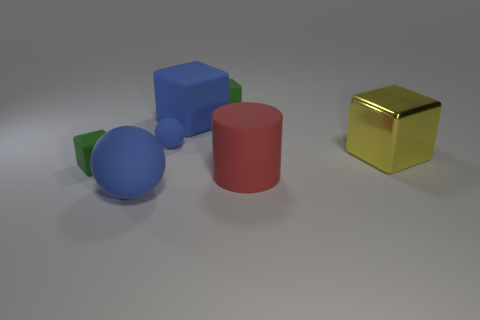How many cubes are made of the same material as the large red cylinder?
Give a very brief answer. 3. What number of shiny cubes are the same size as the rubber cylinder?
Give a very brief answer. 1. What material is the blue ball in front of the green rubber cube that is on the left side of the small blue thing behind the red rubber cylinder made of?
Offer a very short reply. Rubber. What number of things are small green metallic cubes or big red rubber objects?
Offer a terse response. 1. Are there any other things that have the same material as the yellow block?
Offer a terse response. No. There is a tiny blue thing; what shape is it?
Keep it short and to the point. Sphere. The green thing that is in front of the green rubber thing behind the yellow object is what shape?
Provide a succinct answer. Cube. Are the large object that is in front of the red thing and the big red object made of the same material?
Your answer should be compact. Yes. What number of blue objects are large blocks or cylinders?
Keep it short and to the point. 1. Are there any objects of the same color as the large matte ball?
Offer a very short reply. Yes. 